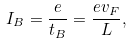Convert formula to latex. <formula><loc_0><loc_0><loc_500><loc_500>I _ { B } = \frac { e } { t _ { B } } = \frac { e v _ { F } } { L } ,</formula> 